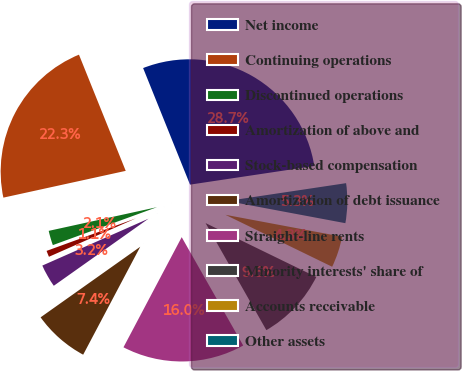<chart> <loc_0><loc_0><loc_500><loc_500><pie_chart><fcel>Net income<fcel>Continuing operations<fcel>Discontinued operations<fcel>Amortization of above and<fcel>Stock-based compensation<fcel>Amortization of debt issuance<fcel>Straight-line rents<fcel>Minority interests' share of<fcel>Accounts receivable<fcel>Other assets<nl><fcel>28.72%<fcel>22.34%<fcel>2.13%<fcel>1.06%<fcel>3.19%<fcel>7.45%<fcel>15.96%<fcel>9.57%<fcel>4.26%<fcel>5.32%<nl></chart> 